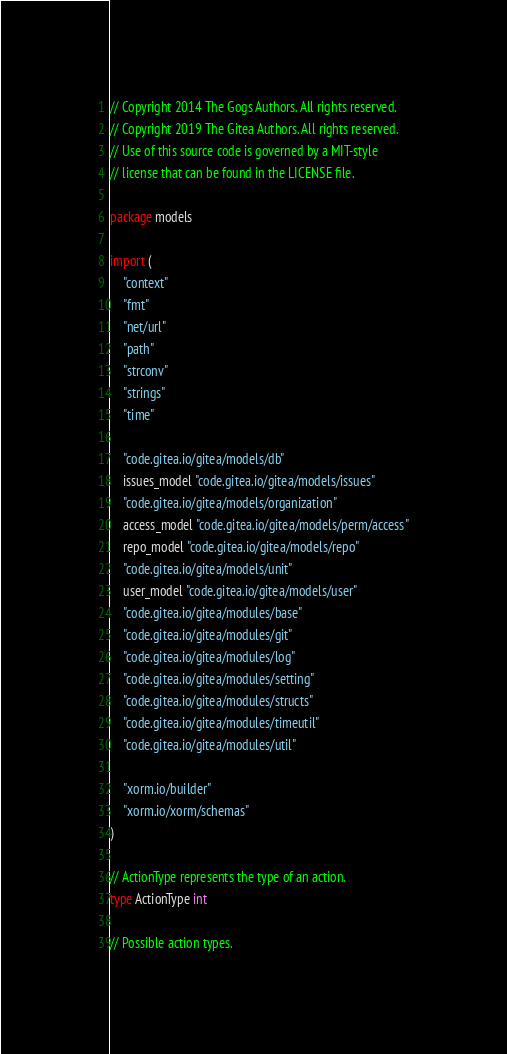<code> <loc_0><loc_0><loc_500><loc_500><_Go_>// Copyright 2014 The Gogs Authors. All rights reserved.
// Copyright 2019 The Gitea Authors. All rights reserved.
// Use of this source code is governed by a MIT-style
// license that can be found in the LICENSE file.

package models

import (
	"context"
	"fmt"
	"net/url"
	"path"
	"strconv"
	"strings"
	"time"

	"code.gitea.io/gitea/models/db"
	issues_model "code.gitea.io/gitea/models/issues"
	"code.gitea.io/gitea/models/organization"
	access_model "code.gitea.io/gitea/models/perm/access"
	repo_model "code.gitea.io/gitea/models/repo"
	"code.gitea.io/gitea/models/unit"
	user_model "code.gitea.io/gitea/models/user"
	"code.gitea.io/gitea/modules/base"
	"code.gitea.io/gitea/modules/git"
	"code.gitea.io/gitea/modules/log"
	"code.gitea.io/gitea/modules/setting"
	"code.gitea.io/gitea/modules/structs"
	"code.gitea.io/gitea/modules/timeutil"
	"code.gitea.io/gitea/modules/util"

	"xorm.io/builder"
	"xorm.io/xorm/schemas"
)

// ActionType represents the type of an action.
type ActionType int

// Possible action types.</code> 